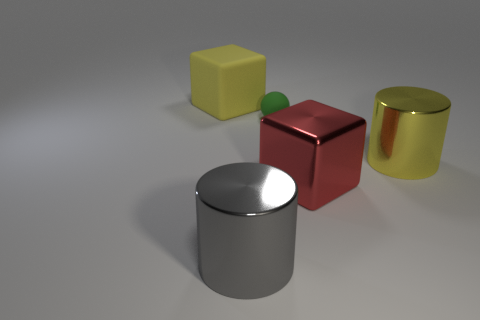There is a metal thing left of the green matte object on the left side of the large block that is right of the small green ball; what is its shape?
Offer a very short reply. Cylinder. How many other things are the same color as the rubber cube?
Provide a succinct answer. 1. What shape is the yellow thing that is in front of the yellow object that is on the left side of the tiny ball?
Give a very brief answer. Cylinder. How many cylinders are on the left side of the large yellow cylinder?
Make the answer very short. 1. Are there any large brown balls made of the same material as the red thing?
Offer a terse response. No. There is a yellow cylinder that is the same size as the red object; what material is it?
Provide a short and direct response. Metal. There is a thing that is to the left of the large red metal thing and on the right side of the big gray metallic cylinder; how big is it?
Make the answer very short. Small. What color is the big object that is on the left side of the small green sphere and behind the big gray cylinder?
Your response must be concise. Yellow. Is the number of large shiny cubes behind the big yellow matte cube less than the number of big gray shiny cylinders on the right side of the big yellow cylinder?
Make the answer very short. No. How many other big shiny things have the same shape as the gray object?
Keep it short and to the point. 1. 